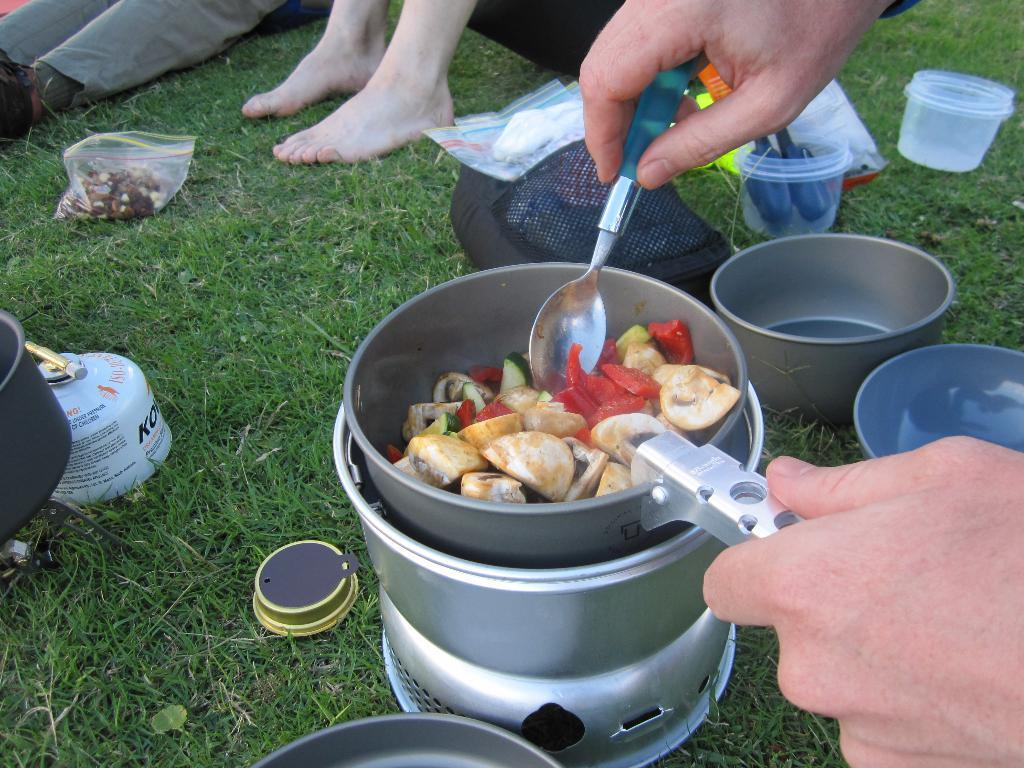How many people are in the image? There are people in the image, but the exact number is not specified. What is one of the people doing in the image? One person is cooking in the image. What type of containers are visible in the image? There are bowls in the image. What are the plastic covers used for in the image? The plastic covers are used to cover or protect something in the image. What type of surface is the cooking taking place on in the image? The cooking is taking place on the grass in the image. What type of lawyer is present in the image? There is no mention of a lawyer in the image. 